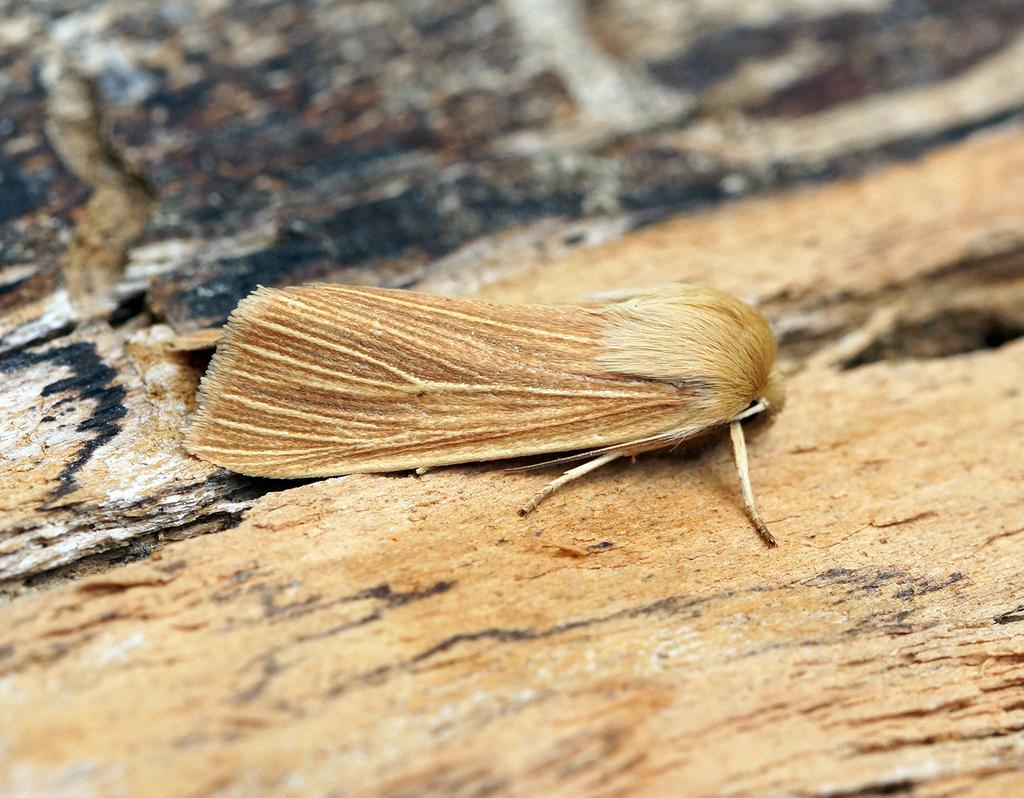Please provide a concise description of this image. In this image we can see fly on the ground. 